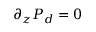<formula> <loc_0><loc_0><loc_500><loc_500>\partial _ { z } P _ { d } = 0</formula> 